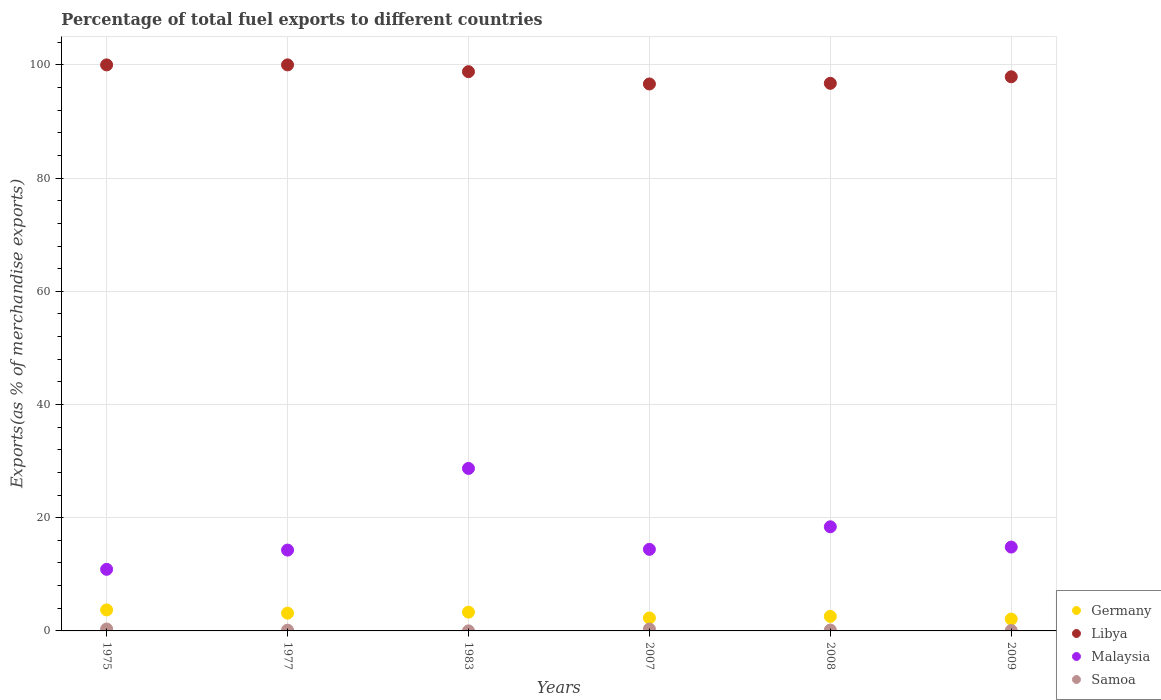How many different coloured dotlines are there?
Make the answer very short. 4. What is the percentage of exports to different countries in Libya in 1983?
Give a very brief answer. 98.8. Across all years, what is the maximum percentage of exports to different countries in Samoa?
Provide a succinct answer. 0.34. Across all years, what is the minimum percentage of exports to different countries in Germany?
Keep it short and to the point. 2.1. In which year was the percentage of exports to different countries in Libya maximum?
Offer a terse response. 1977. What is the total percentage of exports to different countries in Germany in the graph?
Give a very brief answer. 17.13. What is the difference between the percentage of exports to different countries in Germany in 2008 and that in 2009?
Ensure brevity in your answer.  0.47. What is the difference between the percentage of exports to different countries in Samoa in 1975 and the percentage of exports to different countries in Germany in 2009?
Offer a terse response. -1.76. What is the average percentage of exports to different countries in Germany per year?
Your answer should be very brief. 2.85. In the year 1983, what is the difference between the percentage of exports to different countries in Samoa and percentage of exports to different countries in Libya?
Keep it short and to the point. -98.79. In how many years, is the percentage of exports to different countries in Germany greater than 20 %?
Give a very brief answer. 0. What is the ratio of the percentage of exports to different countries in Libya in 1975 to that in 1983?
Keep it short and to the point. 1.01. Is the difference between the percentage of exports to different countries in Samoa in 1977 and 1983 greater than the difference between the percentage of exports to different countries in Libya in 1977 and 1983?
Your answer should be very brief. No. What is the difference between the highest and the second highest percentage of exports to different countries in Malaysia?
Ensure brevity in your answer.  10.31. What is the difference between the highest and the lowest percentage of exports to different countries in Samoa?
Your response must be concise. 0.33. In how many years, is the percentage of exports to different countries in Malaysia greater than the average percentage of exports to different countries in Malaysia taken over all years?
Give a very brief answer. 2. Is it the case that in every year, the sum of the percentage of exports to different countries in Malaysia and percentage of exports to different countries in Libya  is greater than the percentage of exports to different countries in Samoa?
Provide a succinct answer. Yes. How many dotlines are there?
Ensure brevity in your answer.  4. What is the difference between two consecutive major ticks on the Y-axis?
Offer a terse response. 20. Does the graph contain grids?
Your answer should be very brief. Yes. How are the legend labels stacked?
Offer a terse response. Vertical. What is the title of the graph?
Keep it short and to the point. Percentage of total fuel exports to different countries. Does "New Caledonia" appear as one of the legend labels in the graph?
Provide a succinct answer. No. What is the label or title of the Y-axis?
Your answer should be compact. Exports(as % of merchandise exports). What is the Exports(as % of merchandise exports) in Germany in 1975?
Your response must be concise. 3.71. What is the Exports(as % of merchandise exports) of Libya in 1975?
Your answer should be compact. 99.99. What is the Exports(as % of merchandise exports) of Malaysia in 1975?
Provide a succinct answer. 10.88. What is the Exports(as % of merchandise exports) of Samoa in 1975?
Provide a succinct answer. 0.34. What is the Exports(as % of merchandise exports) in Germany in 1977?
Offer a very short reply. 3.14. What is the Exports(as % of merchandise exports) in Libya in 1977?
Provide a short and direct response. 100. What is the Exports(as % of merchandise exports) of Malaysia in 1977?
Make the answer very short. 14.28. What is the Exports(as % of merchandise exports) of Samoa in 1977?
Your answer should be very brief. 0.13. What is the Exports(as % of merchandise exports) in Germany in 1983?
Give a very brief answer. 3.32. What is the Exports(as % of merchandise exports) in Libya in 1983?
Provide a short and direct response. 98.8. What is the Exports(as % of merchandise exports) in Malaysia in 1983?
Offer a terse response. 28.71. What is the Exports(as % of merchandise exports) of Samoa in 1983?
Your answer should be compact. 0.01. What is the Exports(as % of merchandise exports) in Germany in 2007?
Your response must be concise. 2.29. What is the Exports(as % of merchandise exports) in Libya in 2007?
Your answer should be compact. 96.62. What is the Exports(as % of merchandise exports) in Malaysia in 2007?
Keep it short and to the point. 14.41. What is the Exports(as % of merchandise exports) in Samoa in 2007?
Your response must be concise. 0.33. What is the Exports(as % of merchandise exports) of Germany in 2008?
Your answer should be compact. 2.57. What is the Exports(as % of merchandise exports) of Libya in 2008?
Make the answer very short. 96.74. What is the Exports(as % of merchandise exports) of Malaysia in 2008?
Keep it short and to the point. 18.4. What is the Exports(as % of merchandise exports) in Samoa in 2008?
Keep it short and to the point. 0.16. What is the Exports(as % of merchandise exports) in Germany in 2009?
Make the answer very short. 2.1. What is the Exports(as % of merchandise exports) of Libya in 2009?
Ensure brevity in your answer.  97.89. What is the Exports(as % of merchandise exports) in Malaysia in 2009?
Your response must be concise. 14.81. What is the Exports(as % of merchandise exports) in Samoa in 2009?
Offer a terse response. 0.07. Across all years, what is the maximum Exports(as % of merchandise exports) of Germany?
Provide a succinct answer. 3.71. Across all years, what is the maximum Exports(as % of merchandise exports) of Libya?
Your response must be concise. 100. Across all years, what is the maximum Exports(as % of merchandise exports) in Malaysia?
Provide a succinct answer. 28.71. Across all years, what is the maximum Exports(as % of merchandise exports) of Samoa?
Keep it short and to the point. 0.34. Across all years, what is the minimum Exports(as % of merchandise exports) of Germany?
Provide a short and direct response. 2.1. Across all years, what is the minimum Exports(as % of merchandise exports) in Libya?
Provide a short and direct response. 96.62. Across all years, what is the minimum Exports(as % of merchandise exports) in Malaysia?
Your response must be concise. 10.88. Across all years, what is the minimum Exports(as % of merchandise exports) of Samoa?
Provide a short and direct response. 0.01. What is the total Exports(as % of merchandise exports) of Germany in the graph?
Offer a terse response. 17.13. What is the total Exports(as % of merchandise exports) of Libya in the graph?
Offer a very short reply. 590.05. What is the total Exports(as % of merchandise exports) in Malaysia in the graph?
Your answer should be very brief. 101.49. What is the total Exports(as % of merchandise exports) in Samoa in the graph?
Make the answer very short. 1.04. What is the difference between the Exports(as % of merchandise exports) in Germany in 1975 and that in 1977?
Give a very brief answer. 0.57. What is the difference between the Exports(as % of merchandise exports) of Libya in 1975 and that in 1977?
Your response must be concise. -0. What is the difference between the Exports(as % of merchandise exports) in Malaysia in 1975 and that in 1977?
Your answer should be very brief. -3.4. What is the difference between the Exports(as % of merchandise exports) in Samoa in 1975 and that in 1977?
Make the answer very short. 0.2. What is the difference between the Exports(as % of merchandise exports) in Germany in 1975 and that in 1983?
Provide a succinct answer. 0.39. What is the difference between the Exports(as % of merchandise exports) of Libya in 1975 and that in 1983?
Keep it short and to the point. 1.2. What is the difference between the Exports(as % of merchandise exports) of Malaysia in 1975 and that in 1983?
Offer a terse response. -17.83. What is the difference between the Exports(as % of merchandise exports) in Samoa in 1975 and that in 1983?
Offer a terse response. 0.33. What is the difference between the Exports(as % of merchandise exports) of Germany in 1975 and that in 2007?
Provide a succinct answer. 1.42. What is the difference between the Exports(as % of merchandise exports) in Libya in 1975 and that in 2007?
Offer a very short reply. 3.37. What is the difference between the Exports(as % of merchandise exports) of Malaysia in 1975 and that in 2007?
Provide a succinct answer. -3.53. What is the difference between the Exports(as % of merchandise exports) of Samoa in 1975 and that in 2007?
Offer a very short reply. 0. What is the difference between the Exports(as % of merchandise exports) of Germany in 1975 and that in 2008?
Your response must be concise. 1.15. What is the difference between the Exports(as % of merchandise exports) in Libya in 1975 and that in 2008?
Offer a very short reply. 3.26. What is the difference between the Exports(as % of merchandise exports) in Malaysia in 1975 and that in 2008?
Your answer should be compact. -7.52. What is the difference between the Exports(as % of merchandise exports) of Samoa in 1975 and that in 2008?
Offer a terse response. 0.18. What is the difference between the Exports(as % of merchandise exports) of Germany in 1975 and that in 2009?
Offer a very short reply. 1.61. What is the difference between the Exports(as % of merchandise exports) in Libya in 1975 and that in 2009?
Offer a terse response. 2.1. What is the difference between the Exports(as % of merchandise exports) of Malaysia in 1975 and that in 2009?
Offer a very short reply. -3.93. What is the difference between the Exports(as % of merchandise exports) of Samoa in 1975 and that in 2009?
Your answer should be compact. 0.26. What is the difference between the Exports(as % of merchandise exports) of Germany in 1977 and that in 1983?
Provide a succinct answer. -0.18. What is the difference between the Exports(as % of merchandise exports) of Libya in 1977 and that in 1983?
Make the answer very short. 1.2. What is the difference between the Exports(as % of merchandise exports) in Malaysia in 1977 and that in 1983?
Ensure brevity in your answer.  -14.43. What is the difference between the Exports(as % of merchandise exports) in Samoa in 1977 and that in 1983?
Your response must be concise. 0.12. What is the difference between the Exports(as % of merchandise exports) of Germany in 1977 and that in 2007?
Your answer should be compact. 0.85. What is the difference between the Exports(as % of merchandise exports) in Libya in 1977 and that in 2007?
Offer a very short reply. 3.37. What is the difference between the Exports(as % of merchandise exports) of Malaysia in 1977 and that in 2007?
Your answer should be compact. -0.13. What is the difference between the Exports(as % of merchandise exports) of Samoa in 1977 and that in 2007?
Your answer should be very brief. -0.2. What is the difference between the Exports(as % of merchandise exports) in Germany in 1977 and that in 2008?
Provide a succinct answer. 0.58. What is the difference between the Exports(as % of merchandise exports) in Libya in 1977 and that in 2008?
Your answer should be compact. 3.26. What is the difference between the Exports(as % of merchandise exports) of Malaysia in 1977 and that in 2008?
Your response must be concise. -4.12. What is the difference between the Exports(as % of merchandise exports) in Samoa in 1977 and that in 2008?
Give a very brief answer. -0.03. What is the difference between the Exports(as % of merchandise exports) of Germany in 1977 and that in 2009?
Ensure brevity in your answer.  1.04. What is the difference between the Exports(as % of merchandise exports) in Libya in 1977 and that in 2009?
Provide a short and direct response. 2.1. What is the difference between the Exports(as % of merchandise exports) in Malaysia in 1977 and that in 2009?
Provide a succinct answer. -0.53. What is the difference between the Exports(as % of merchandise exports) of Samoa in 1977 and that in 2009?
Your answer should be compact. 0.06. What is the difference between the Exports(as % of merchandise exports) in Germany in 1983 and that in 2007?
Provide a short and direct response. 1.03. What is the difference between the Exports(as % of merchandise exports) of Libya in 1983 and that in 2007?
Offer a very short reply. 2.17. What is the difference between the Exports(as % of merchandise exports) in Malaysia in 1983 and that in 2007?
Keep it short and to the point. 14.29. What is the difference between the Exports(as % of merchandise exports) in Samoa in 1983 and that in 2007?
Offer a very short reply. -0.32. What is the difference between the Exports(as % of merchandise exports) in Germany in 1983 and that in 2008?
Offer a terse response. 0.75. What is the difference between the Exports(as % of merchandise exports) of Libya in 1983 and that in 2008?
Ensure brevity in your answer.  2.06. What is the difference between the Exports(as % of merchandise exports) of Malaysia in 1983 and that in 2008?
Ensure brevity in your answer.  10.31. What is the difference between the Exports(as % of merchandise exports) in Samoa in 1983 and that in 2008?
Your response must be concise. -0.15. What is the difference between the Exports(as % of merchandise exports) in Germany in 1983 and that in 2009?
Your response must be concise. 1.22. What is the difference between the Exports(as % of merchandise exports) in Libya in 1983 and that in 2009?
Your response must be concise. 0.9. What is the difference between the Exports(as % of merchandise exports) in Malaysia in 1983 and that in 2009?
Your answer should be very brief. 13.89. What is the difference between the Exports(as % of merchandise exports) in Samoa in 1983 and that in 2009?
Make the answer very short. -0.06. What is the difference between the Exports(as % of merchandise exports) in Germany in 2007 and that in 2008?
Offer a very short reply. -0.27. What is the difference between the Exports(as % of merchandise exports) of Libya in 2007 and that in 2008?
Offer a terse response. -0.11. What is the difference between the Exports(as % of merchandise exports) in Malaysia in 2007 and that in 2008?
Provide a succinct answer. -3.98. What is the difference between the Exports(as % of merchandise exports) in Samoa in 2007 and that in 2008?
Make the answer very short. 0.17. What is the difference between the Exports(as % of merchandise exports) of Germany in 2007 and that in 2009?
Give a very brief answer. 0.2. What is the difference between the Exports(as % of merchandise exports) of Libya in 2007 and that in 2009?
Make the answer very short. -1.27. What is the difference between the Exports(as % of merchandise exports) of Malaysia in 2007 and that in 2009?
Provide a short and direct response. -0.4. What is the difference between the Exports(as % of merchandise exports) of Samoa in 2007 and that in 2009?
Offer a terse response. 0.26. What is the difference between the Exports(as % of merchandise exports) in Germany in 2008 and that in 2009?
Keep it short and to the point. 0.47. What is the difference between the Exports(as % of merchandise exports) of Libya in 2008 and that in 2009?
Your answer should be compact. -1.16. What is the difference between the Exports(as % of merchandise exports) of Malaysia in 2008 and that in 2009?
Provide a short and direct response. 3.58. What is the difference between the Exports(as % of merchandise exports) in Samoa in 2008 and that in 2009?
Your response must be concise. 0.09. What is the difference between the Exports(as % of merchandise exports) in Germany in 1975 and the Exports(as % of merchandise exports) in Libya in 1977?
Make the answer very short. -96.29. What is the difference between the Exports(as % of merchandise exports) of Germany in 1975 and the Exports(as % of merchandise exports) of Malaysia in 1977?
Ensure brevity in your answer.  -10.57. What is the difference between the Exports(as % of merchandise exports) of Germany in 1975 and the Exports(as % of merchandise exports) of Samoa in 1977?
Your response must be concise. 3.58. What is the difference between the Exports(as % of merchandise exports) of Libya in 1975 and the Exports(as % of merchandise exports) of Malaysia in 1977?
Give a very brief answer. 85.71. What is the difference between the Exports(as % of merchandise exports) of Libya in 1975 and the Exports(as % of merchandise exports) of Samoa in 1977?
Give a very brief answer. 99.86. What is the difference between the Exports(as % of merchandise exports) of Malaysia in 1975 and the Exports(as % of merchandise exports) of Samoa in 1977?
Keep it short and to the point. 10.75. What is the difference between the Exports(as % of merchandise exports) in Germany in 1975 and the Exports(as % of merchandise exports) in Libya in 1983?
Offer a very short reply. -95.09. What is the difference between the Exports(as % of merchandise exports) in Germany in 1975 and the Exports(as % of merchandise exports) in Malaysia in 1983?
Keep it short and to the point. -24.99. What is the difference between the Exports(as % of merchandise exports) of Germany in 1975 and the Exports(as % of merchandise exports) of Samoa in 1983?
Provide a short and direct response. 3.7. What is the difference between the Exports(as % of merchandise exports) in Libya in 1975 and the Exports(as % of merchandise exports) in Malaysia in 1983?
Make the answer very short. 71.29. What is the difference between the Exports(as % of merchandise exports) of Libya in 1975 and the Exports(as % of merchandise exports) of Samoa in 1983?
Ensure brevity in your answer.  99.98. What is the difference between the Exports(as % of merchandise exports) in Malaysia in 1975 and the Exports(as % of merchandise exports) in Samoa in 1983?
Your answer should be compact. 10.87. What is the difference between the Exports(as % of merchandise exports) in Germany in 1975 and the Exports(as % of merchandise exports) in Libya in 2007?
Give a very brief answer. -92.91. What is the difference between the Exports(as % of merchandise exports) in Germany in 1975 and the Exports(as % of merchandise exports) in Malaysia in 2007?
Provide a short and direct response. -10.7. What is the difference between the Exports(as % of merchandise exports) in Germany in 1975 and the Exports(as % of merchandise exports) in Samoa in 2007?
Make the answer very short. 3.38. What is the difference between the Exports(as % of merchandise exports) of Libya in 1975 and the Exports(as % of merchandise exports) of Malaysia in 2007?
Provide a short and direct response. 85.58. What is the difference between the Exports(as % of merchandise exports) in Libya in 1975 and the Exports(as % of merchandise exports) in Samoa in 2007?
Ensure brevity in your answer.  99.66. What is the difference between the Exports(as % of merchandise exports) in Malaysia in 1975 and the Exports(as % of merchandise exports) in Samoa in 2007?
Your answer should be compact. 10.55. What is the difference between the Exports(as % of merchandise exports) of Germany in 1975 and the Exports(as % of merchandise exports) of Libya in 2008?
Provide a succinct answer. -93.03. What is the difference between the Exports(as % of merchandise exports) in Germany in 1975 and the Exports(as % of merchandise exports) in Malaysia in 2008?
Provide a succinct answer. -14.68. What is the difference between the Exports(as % of merchandise exports) of Germany in 1975 and the Exports(as % of merchandise exports) of Samoa in 2008?
Your answer should be very brief. 3.55. What is the difference between the Exports(as % of merchandise exports) in Libya in 1975 and the Exports(as % of merchandise exports) in Malaysia in 2008?
Provide a short and direct response. 81.6. What is the difference between the Exports(as % of merchandise exports) in Libya in 1975 and the Exports(as % of merchandise exports) in Samoa in 2008?
Your answer should be compact. 99.83. What is the difference between the Exports(as % of merchandise exports) in Malaysia in 1975 and the Exports(as % of merchandise exports) in Samoa in 2008?
Offer a very short reply. 10.72. What is the difference between the Exports(as % of merchandise exports) of Germany in 1975 and the Exports(as % of merchandise exports) of Libya in 2009?
Your answer should be compact. -94.18. What is the difference between the Exports(as % of merchandise exports) of Germany in 1975 and the Exports(as % of merchandise exports) of Malaysia in 2009?
Offer a very short reply. -11.1. What is the difference between the Exports(as % of merchandise exports) of Germany in 1975 and the Exports(as % of merchandise exports) of Samoa in 2009?
Ensure brevity in your answer.  3.64. What is the difference between the Exports(as % of merchandise exports) of Libya in 1975 and the Exports(as % of merchandise exports) of Malaysia in 2009?
Keep it short and to the point. 85.18. What is the difference between the Exports(as % of merchandise exports) in Libya in 1975 and the Exports(as % of merchandise exports) in Samoa in 2009?
Give a very brief answer. 99.92. What is the difference between the Exports(as % of merchandise exports) of Malaysia in 1975 and the Exports(as % of merchandise exports) of Samoa in 2009?
Ensure brevity in your answer.  10.81. What is the difference between the Exports(as % of merchandise exports) of Germany in 1977 and the Exports(as % of merchandise exports) of Libya in 1983?
Your response must be concise. -95.66. What is the difference between the Exports(as % of merchandise exports) in Germany in 1977 and the Exports(as % of merchandise exports) in Malaysia in 1983?
Offer a very short reply. -25.56. What is the difference between the Exports(as % of merchandise exports) in Germany in 1977 and the Exports(as % of merchandise exports) in Samoa in 1983?
Offer a terse response. 3.13. What is the difference between the Exports(as % of merchandise exports) in Libya in 1977 and the Exports(as % of merchandise exports) in Malaysia in 1983?
Your response must be concise. 71.29. What is the difference between the Exports(as % of merchandise exports) in Libya in 1977 and the Exports(as % of merchandise exports) in Samoa in 1983?
Your answer should be compact. 99.99. What is the difference between the Exports(as % of merchandise exports) in Malaysia in 1977 and the Exports(as % of merchandise exports) in Samoa in 1983?
Your answer should be compact. 14.27. What is the difference between the Exports(as % of merchandise exports) in Germany in 1977 and the Exports(as % of merchandise exports) in Libya in 2007?
Provide a succinct answer. -93.48. What is the difference between the Exports(as % of merchandise exports) in Germany in 1977 and the Exports(as % of merchandise exports) in Malaysia in 2007?
Provide a short and direct response. -11.27. What is the difference between the Exports(as % of merchandise exports) in Germany in 1977 and the Exports(as % of merchandise exports) in Samoa in 2007?
Your answer should be compact. 2.81. What is the difference between the Exports(as % of merchandise exports) in Libya in 1977 and the Exports(as % of merchandise exports) in Malaysia in 2007?
Offer a very short reply. 85.59. What is the difference between the Exports(as % of merchandise exports) of Libya in 1977 and the Exports(as % of merchandise exports) of Samoa in 2007?
Ensure brevity in your answer.  99.66. What is the difference between the Exports(as % of merchandise exports) in Malaysia in 1977 and the Exports(as % of merchandise exports) in Samoa in 2007?
Offer a very short reply. 13.95. What is the difference between the Exports(as % of merchandise exports) in Germany in 1977 and the Exports(as % of merchandise exports) in Libya in 2008?
Keep it short and to the point. -93.6. What is the difference between the Exports(as % of merchandise exports) in Germany in 1977 and the Exports(as % of merchandise exports) in Malaysia in 2008?
Your answer should be very brief. -15.26. What is the difference between the Exports(as % of merchandise exports) of Germany in 1977 and the Exports(as % of merchandise exports) of Samoa in 2008?
Your answer should be compact. 2.98. What is the difference between the Exports(as % of merchandise exports) of Libya in 1977 and the Exports(as % of merchandise exports) of Malaysia in 2008?
Ensure brevity in your answer.  81.6. What is the difference between the Exports(as % of merchandise exports) in Libya in 1977 and the Exports(as % of merchandise exports) in Samoa in 2008?
Give a very brief answer. 99.84. What is the difference between the Exports(as % of merchandise exports) of Malaysia in 1977 and the Exports(as % of merchandise exports) of Samoa in 2008?
Your response must be concise. 14.12. What is the difference between the Exports(as % of merchandise exports) in Germany in 1977 and the Exports(as % of merchandise exports) in Libya in 2009?
Keep it short and to the point. -94.75. What is the difference between the Exports(as % of merchandise exports) of Germany in 1977 and the Exports(as % of merchandise exports) of Malaysia in 2009?
Provide a short and direct response. -11.67. What is the difference between the Exports(as % of merchandise exports) in Germany in 1977 and the Exports(as % of merchandise exports) in Samoa in 2009?
Offer a very short reply. 3.07. What is the difference between the Exports(as % of merchandise exports) in Libya in 1977 and the Exports(as % of merchandise exports) in Malaysia in 2009?
Keep it short and to the point. 85.19. What is the difference between the Exports(as % of merchandise exports) in Libya in 1977 and the Exports(as % of merchandise exports) in Samoa in 2009?
Provide a succinct answer. 99.93. What is the difference between the Exports(as % of merchandise exports) in Malaysia in 1977 and the Exports(as % of merchandise exports) in Samoa in 2009?
Offer a very short reply. 14.21. What is the difference between the Exports(as % of merchandise exports) of Germany in 1983 and the Exports(as % of merchandise exports) of Libya in 2007?
Keep it short and to the point. -93.31. What is the difference between the Exports(as % of merchandise exports) of Germany in 1983 and the Exports(as % of merchandise exports) of Malaysia in 2007?
Your answer should be very brief. -11.09. What is the difference between the Exports(as % of merchandise exports) in Germany in 1983 and the Exports(as % of merchandise exports) in Samoa in 2007?
Keep it short and to the point. 2.99. What is the difference between the Exports(as % of merchandise exports) in Libya in 1983 and the Exports(as % of merchandise exports) in Malaysia in 2007?
Keep it short and to the point. 84.39. What is the difference between the Exports(as % of merchandise exports) of Libya in 1983 and the Exports(as % of merchandise exports) of Samoa in 2007?
Give a very brief answer. 98.46. What is the difference between the Exports(as % of merchandise exports) of Malaysia in 1983 and the Exports(as % of merchandise exports) of Samoa in 2007?
Offer a very short reply. 28.37. What is the difference between the Exports(as % of merchandise exports) of Germany in 1983 and the Exports(as % of merchandise exports) of Libya in 2008?
Your answer should be very brief. -93.42. What is the difference between the Exports(as % of merchandise exports) of Germany in 1983 and the Exports(as % of merchandise exports) of Malaysia in 2008?
Provide a short and direct response. -15.08. What is the difference between the Exports(as % of merchandise exports) of Germany in 1983 and the Exports(as % of merchandise exports) of Samoa in 2008?
Offer a very short reply. 3.16. What is the difference between the Exports(as % of merchandise exports) of Libya in 1983 and the Exports(as % of merchandise exports) of Malaysia in 2008?
Offer a terse response. 80.4. What is the difference between the Exports(as % of merchandise exports) in Libya in 1983 and the Exports(as % of merchandise exports) in Samoa in 2008?
Offer a very short reply. 98.64. What is the difference between the Exports(as % of merchandise exports) of Malaysia in 1983 and the Exports(as % of merchandise exports) of Samoa in 2008?
Provide a succinct answer. 28.55. What is the difference between the Exports(as % of merchandise exports) of Germany in 1983 and the Exports(as % of merchandise exports) of Libya in 2009?
Provide a succinct answer. -94.58. What is the difference between the Exports(as % of merchandise exports) in Germany in 1983 and the Exports(as % of merchandise exports) in Malaysia in 2009?
Your answer should be very brief. -11.49. What is the difference between the Exports(as % of merchandise exports) in Germany in 1983 and the Exports(as % of merchandise exports) in Samoa in 2009?
Give a very brief answer. 3.25. What is the difference between the Exports(as % of merchandise exports) of Libya in 1983 and the Exports(as % of merchandise exports) of Malaysia in 2009?
Give a very brief answer. 83.99. What is the difference between the Exports(as % of merchandise exports) in Libya in 1983 and the Exports(as % of merchandise exports) in Samoa in 2009?
Your answer should be compact. 98.73. What is the difference between the Exports(as % of merchandise exports) of Malaysia in 1983 and the Exports(as % of merchandise exports) of Samoa in 2009?
Give a very brief answer. 28.64. What is the difference between the Exports(as % of merchandise exports) of Germany in 2007 and the Exports(as % of merchandise exports) of Libya in 2008?
Keep it short and to the point. -94.44. What is the difference between the Exports(as % of merchandise exports) of Germany in 2007 and the Exports(as % of merchandise exports) of Malaysia in 2008?
Keep it short and to the point. -16.1. What is the difference between the Exports(as % of merchandise exports) in Germany in 2007 and the Exports(as % of merchandise exports) in Samoa in 2008?
Your answer should be very brief. 2.13. What is the difference between the Exports(as % of merchandise exports) in Libya in 2007 and the Exports(as % of merchandise exports) in Malaysia in 2008?
Give a very brief answer. 78.23. What is the difference between the Exports(as % of merchandise exports) in Libya in 2007 and the Exports(as % of merchandise exports) in Samoa in 2008?
Your response must be concise. 96.46. What is the difference between the Exports(as % of merchandise exports) in Malaysia in 2007 and the Exports(as % of merchandise exports) in Samoa in 2008?
Provide a succinct answer. 14.25. What is the difference between the Exports(as % of merchandise exports) in Germany in 2007 and the Exports(as % of merchandise exports) in Libya in 2009?
Your answer should be compact. -95.6. What is the difference between the Exports(as % of merchandise exports) in Germany in 2007 and the Exports(as % of merchandise exports) in Malaysia in 2009?
Make the answer very short. -12.52. What is the difference between the Exports(as % of merchandise exports) of Germany in 2007 and the Exports(as % of merchandise exports) of Samoa in 2009?
Your answer should be very brief. 2.22. What is the difference between the Exports(as % of merchandise exports) of Libya in 2007 and the Exports(as % of merchandise exports) of Malaysia in 2009?
Provide a succinct answer. 81.81. What is the difference between the Exports(as % of merchandise exports) of Libya in 2007 and the Exports(as % of merchandise exports) of Samoa in 2009?
Provide a short and direct response. 96.55. What is the difference between the Exports(as % of merchandise exports) in Malaysia in 2007 and the Exports(as % of merchandise exports) in Samoa in 2009?
Make the answer very short. 14.34. What is the difference between the Exports(as % of merchandise exports) in Germany in 2008 and the Exports(as % of merchandise exports) in Libya in 2009?
Keep it short and to the point. -95.33. What is the difference between the Exports(as % of merchandise exports) of Germany in 2008 and the Exports(as % of merchandise exports) of Malaysia in 2009?
Keep it short and to the point. -12.25. What is the difference between the Exports(as % of merchandise exports) of Germany in 2008 and the Exports(as % of merchandise exports) of Samoa in 2009?
Keep it short and to the point. 2.5. What is the difference between the Exports(as % of merchandise exports) of Libya in 2008 and the Exports(as % of merchandise exports) of Malaysia in 2009?
Your answer should be very brief. 81.93. What is the difference between the Exports(as % of merchandise exports) of Libya in 2008 and the Exports(as % of merchandise exports) of Samoa in 2009?
Make the answer very short. 96.67. What is the difference between the Exports(as % of merchandise exports) of Malaysia in 2008 and the Exports(as % of merchandise exports) of Samoa in 2009?
Provide a short and direct response. 18.33. What is the average Exports(as % of merchandise exports) in Germany per year?
Make the answer very short. 2.85. What is the average Exports(as % of merchandise exports) in Libya per year?
Make the answer very short. 98.34. What is the average Exports(as % of merchandise exports) of Malaysia per year?
Keep it short and to the point. 16.91. What is the average Exports(as % of merchandise exports) of Samoa per year?
Provide a succinct answer. 0.17. In the year 1975, what is the difference between the Exports(as % of merchandise exports) of Germany and Exports(as % of merchandise exports) of Libya?
Your response must be concise. -96.28. In the year 1975, what is the difference between the Exports(as % of merchandise exports) of Germany and Exports(as % of merchandise exports) of Malaysia?
Offer a very short reply. -7.17. In the year 1975, what is the difference between the Exports(as % of merchandise exports) in Germany and Exports(as % of merchandise exports) in Samoa?
Your answer should be very brief. 3.38. In the year 1975, what is the difference between the Exports(as % of merchandise exports) of Libya and Exports(as % of merchandise exports) of Malaysia?
Offer a terse response. 89.11. In the year 1975, what is the difference between the Exports(as % of merchandise exports) of Libya and Exports(as % of merchandise exports) of Samoa?
Ensure brevity in your answer.  99.66. In the year 1975, what is the difference between the Exports(as % of merchandise exports) of Malaysia and Exports(as % of merchandise exports) of Samoa?
Offer a terse response. 10.55. In the year 1977, what is the difference between the Exports(as % of merchandise exports) in Germany and Exports(as % of merchandise exports) in Libya?
Your answer should be compact. -96.86. In the year 1977, what is the difference between the Exports(as % of merchandise exports) in Germany and Exports(as % of merchandise exports) in Malaysia?
Ensure brevity in your answer.  -11.14. In the year 1977, what is the difference between the Exports(as % of merchandise exports) of Germany and Exports(as % of merchandise exports) of Samoa?
Provide a succinct answer. 3.01. In the year 1977, what is the difference between the Exports(as % of merchandise exports) in Libya and Exports(as % of merchandise exports) in Malaysia?
Ensure brevity in your answer.  85.72. In the year 1977, what is the difference between the Exports(as % of merchandise exports) of Libya and Exports(as % of merchandise exports) of Samoa?
Keep it short and to the point. 99.87. In the year 1977, what is the difference between the Exports(as % of merchandise exports) in Malaysia and Exports(as % of merchandise exports) in Samoa?
Keep it short and to the point. 14.15. In the year 1983, what is the difference between the Exports(as % of merchandise exports) of Germany and Exports(as % of merchandise exports) of Libya?
Give a very brief answer. -95.48. In the year 1983, what is the difference between the Exports(as % of merchandise exports) of Germany and Exports(as % of merchandise exports) of Malaysia?
Provide a short and direct response. -25.39. In the year 1983, what is the difference between the Exports(as % of merchandise exports) in Germany and Exports(as % of merchandise exports) in Samoa?
Your response must be concise. 3.31. In the year 1983, what is the difference between the Exports(as % of merchandise exports) of Libya and Exports(as % of merchandise exports) of Malaysia?
Make the answer very short. 70.09. In the year 1983, what is the difference between the Exports(as % of merchandise exports) in Libya and Exports(as % of merchandise exports) in Samoa?
Ensure brevity in your answer.  98.79. In the year 1983, what is the difference between the Exports(as % of merchandise exports) of Malaysia and Exports(as % of merchandise exports) of Samoa?
Ensure brevity in your answer.  28.7. In the year 2007, what is the difference between the Exports(as % of merchandise exports) of Germany and Exports(as % of merchandise exports) of Libya?
Give a very brief answer. -94.33. In the year 2007, what is the difference between the Exports(as % of merchandise exports) in Germany and Exports(as % of merchandise exports) in Malaysia?
Your response must be concise. -12.12. In the year 2007, what is the difference between the Exports(as % of merchandise exports) of Germany and Exports(as % of merchandise exports) of Samoa?
Your answer should be very brief. 1.96. In the year 2007, what is the difference between the Exports(as % of merchandise exports) of Libya and Exports(as % of merchandise exports) of Malaysia?
Provide a short and direct response. 82.21. In the year 2007, what is the difference between the Exports(as % of merchandise exports) in Libya and Exports(as % of merchandise exports) in Samoa?
Offer a terse response. 96.29. In the year 2007, what is the difference between the Exports(as % of merchandise exports) in Malaysia and Exports(as % of merchandise exports) in Samoa?
Make the answer very short. 14.08. In the year 2008, what is the difference between the Exports(as % of merchandise exports) in Germany and Exports(as % of merchandise exports) in Libya?
Keep it short and to the point. -94.17. In the year 2008, what is the difference between the Exports(as % of merchandise exports) in Germany and Exports(as % of merchandise exports) in Malaysia?
Offer a terse response. -15.83. In the year 2008, what is the difference between the Exports(as % of merchandise exports) in Germany and Exports(as % of merchandise exports) in Samoa?
Offer a very short reply. 2.41. In the year 2008, what is the difference between the Exports(as % of merchandise exports) in Libya and Exports(as % of merchandise exports) in Malaysia?
Keep it short and to the point. 78.34. In the year 2008, what is the difference between the Exports(as % of merchandise exports) in Libya and Exports(as % of merchandise exports) in Samoa?
Your answer should be very brief. 96.58. In the year 2008, what is the difference between the Exports(as % of merchandise exports) of Malaysia and Exports(as % of merchandise exports) of Samoa?
Make the answer very short. 18.24. In the year 2009, what is the difference between the Exports(as % of merchandise exports) in Germany and Exports(as % of merchandise exports) in Libya?
Your answer should be compact. -95.8. In the year 2009, what is the difference between the Exports(as % of merchandise exports) in Germany and Exports(as % of merchandise exports) in Malaysia?
Ensure brevity in your answer.  -12.71. In the year 2009, what is the difference between the Exports(as % of merchandise exports) of Germany and Exports(as % of merchandise exports) of Samoa?
Provide a short and direct response. 2.03. In the year 2009, what is the difference between the Exports(as % of merchandise exports) in Libya and Exports(as % of merchandise exports) in Malaysia?
Offer a very short reply. 83.08. In the year 2009, what is the difference between the Exports(as % of merchandise exports) in Libya and Exports(as % of merchandise exports) in Samoa?
Your answer should be very brief. 97.82. In the year 2009, what is the difference between the Exports(as % of merchandise exports) in Malaysia and Exports(as % of merchandise exports) in Samoa?
Your response must be concise. 14.74. What is the ratio of the Exports(as % of merchandise exports) in Germany in 1975 to that in 1977?
Provide a short and direct response. 1.18. What is the ratio of the Exports(as % of merchandise exports) in Malaysia in 1975 to that in 1977?
Offer a terse response. 0.76. What is the ratio of the Exports(as % of merchandise exports) in Samoa in 1975 to that in 1977?
Offer a very short reply. 2.54. What is the ratio of the Exports(as % of merchandise exports) of Germany in 1975 to that in 1983?
Offer a very short reply. 1.12. What is the ratio of the Exports(as % of merchandise exports) in Libya in 1975 to that in 1983?
Offer a very short reply. 1.01. What is the ratio of the Exports(as % of merchandise exports) of Malaysia in 1975 to that in 1983?
Provide a succinct answer. 0.38. What is the ratio of the Exports(as % of merchandise exports) of Samoa in 1975 to that in 1983?
Your response must be concise. 37.58. What is the ratio of the Exports(as % of merchandise exports) in Germany in 1975 to that in 2007?
Make the answer very short. 1.62. What is the ratio of the Exports(as % of merchandise exports) of Libya in 1975 to that in 2007?
Your answer should be very brief. 1.03. What is the ratio of the Exports(as % of merchandise exports) of Malaysia in 1975 to that in 2007?
Offer a terse response. 0.76. What is the ratio of the Exports(as % of merchandise exports) of Samoa in 1975 to that in 2007?
Offer a terse response. 1.01. What is the ratio of the Exports(as % of merchandise exports) in Germany in 1975 to that in 2008?
Keep it short and to the point. 1.45. What is the ratio of the Exports(as % of merchandise exports) in Libya in 1975 to that in 2008?
Make the answer very short. 1.03. What is the ratio of the Exports(as % of merchandise exports) of Malaysia in 1975 to that in 2008?
Provide a succinct answer. 0.59. What is the ratio of the Exports(as % of merchandise exports) of Samoa in 1975 to that in 2008?
Keep it short and to the point. 2.1. What is the ratio of the Exports(as % of merchandise exports) of Germany in 1975 to that in 2009?
Your answer should be compact. 1.77. What is the ratio of the Exports(as % of merchandise exports) of Libya in 1975 to that in 2009?
Keep it short and to the point. 1.02. What is the ratio of the Exports(as % of merchandise exports) in Malaysia in 1975 to that in 2009?
Provide a short and direct response. 0.73. What is the ratio of the Exports(as % of merchandise exports) of Samoa in 1975 to that in 2009?
Your response must be concise. 4.72. What is the ratio of the Exports(as % of merchandise exports) in Germany in 1977 to that in 1983?
Ensure brevity in your answer.  0.95. What is the ratio of the Exports(as % of merchandise exports) in Libya in 1977 to that in 1983?
Offer a very short reply. 1.01. What is the ratio of the Exports(as % of merchandise exports) of Malaysia in 1977 to that in 1983?
Provide a short and direct response. 0.5. What is the ratio of the Exports(as % of merchandise exports) of Samoa in 1977 to that in 1983?
Offer a terse response. 14.77. What is the ratio of the Exports(as % of merchandise exports) in Germany in 1977 to that in 2007?
Provide a short and direct response. 1.37. What is the ratio of the Exports(as % of merchandise exports) in Libya in 1977 to that in 2007?
Provide a short and direct response. 1.03. What is the ratio of the Exports(as % of merchandise exports) in Malaysia in 1977 to that in 2007?
Provide a succinct answer. 0.99. What is the ratio of the Exports(as % of merchandise exports) in Samoa in 1977 to that in 2007?
Your answer should be very brief. 0.4. What is the ratio of the Exports(as % of merchandise exports) of Germany in 1977 to that in 2008?
Make the answer very short. 1.22. What is the ratio of the Exports(as % of merchandise exports) in Libya in 1977 to that in 2008?
Provide a succinct answer. 1.03. What is the ratio of the Exports(as % of merchandise exports) of Malaysia in 1977 to that in 2008?
Provide a short and direct response. 0.78. What is the ratio of the Exports(as % of merchandise exports) of Samoa in 1977 to that in 2008?
Make the answer very short. 0.82. What is the ratio of the Exports(as % of merchandise exports) in Germany in 1977 to that in 2009?
Give a very brief answer. 1.5. What is the ratio of the Exports(as % of merchandise exports) in Libya in 1977 to that in 2009?
Offer a terse response. 1.02. What is the ratio of the Exports(as % of merchandise exports) in Malaysia in 1977 to that in 2009?
Provide a short and direct response. 0.96. What is the ratio of the Exports(as % of merchandise exports) in Samoa in 1977 to that in 2009?
Your response must be concise. 1.86. What is the ratio of the Exports(as % of merchandise exports) in Germany in 1983 to that in 2007?
Your answer should be compact. 1.45. What is the ratio of the Exports(as % of merchandise exports) of Libya in 1983 to that in 2007?
Your answer should be compact. 1.02. What is the ratio of the Exports(as % of merchandise exports) in Malaysia in 1983 to that in 2007?
Your answer should be compact. 1.99. What is the ratio of the Exports(as % of merchandise exports) in Samoa in 1983 to that in 2007?
Make the answer very short. 0.03. What is the ratio of the Exports(as % of merchandise exports) in Germany in 1983 to that in 2008?
Your answer should be very brief. 1.29. What is the ratio of the Exports(as % of merchandise exports) in Libya in 1983 to that in 2008?
Your answer should be compact. 1.02. What is the ratio of the Exports(as % of merchandise exports) in Malaysia in 1983 to that in 2008?
Offer a terse response. 1.56. What is the ratio of the Exports(as % of merchandise exports) in Samoa in 1983 to that in 2008?
Offer a terse response. 0.06. What is the ratio of the Exports(as % of merchandise exports) of Germany in 1983 to that in 2009?
Offer a terse response. 1.58. What is the ratio of the Exports(as % of merchandise exports) in Libya in 1983 to that in 2009?
Make the answer very short. 1.01. What is the ratio of the Exports(as % of merchandise exports) of Malaysia in 1983 to that in 2009?
Offer a terse response. 1.94. What is the ratio of the Exports(as % of merchandise exports) of Samoa in 1983 to that in 2009?
Ensure brevity in your answer.  0.13. What is the ratio of the Exports(as % of merchandise exports) of Germany in 2007 to that in 2008?
Ensure brevity in your answer.  0.89. What is the ratio of the Exports(as % of merchandise exports) in Libya in 2007 to that in 2008?
Make the answer very short. 1. What is the ratio of the Exports(as % of merchandise exports) of Malaysia in 2007 to that in 2008?
Provide a short and direct response. 0.78. What is the ratio of the Exports(as % of merchandise exports) in Samoa in 2007 to that in 2008?
Give a very brief answer. 2.08. What is the ratio of the Exports(as % of merchandise exports) in Germany in 2007 to that in 2009?
Offer a terse response. 1.09. What is the ratio of the Exports(as % of merchandise exports) of Samoa in 2007 to that in 2009?
Make the answer very short. 4.69. What is the ratio of the Exports(as % of merchandise exports) of Germany in 2008 to that in 2009?
Make the answer very short. 1.22. What is the ratio of the Exports(as % of merchandise exports) in Malaysia in 2008 to that in 2009?
Your answer should be very brief. 1.24. What is the ratio of the Exports(as % of merchandise exports) of Samoa in 2008 to that in 2009?
Keep it short and to the point. 2.25. What is the difference between the highest and the second highest Exports(as % of merchandise exports) in Germany?
Give a very brief answer. 0.39. What is the difference between the highest and the second highest Exports(as % of merchandise exports) in Libya?
Provide a succinct answer. 0. What is the difference between the highest and the second highest Exports(as % of merchandise exports) of Malaysia?
Your answer should be compact. 10.31. What is the difference between the highest and the second highest Exports(as % of merchandise exports) of Samoa?
Your answer should be very brief. 0. What is the difference between the highest and the lowest Exports(as % of merchandise exports) in Germany?
Offer a terse response. 1.61. What is the difference between the highest and the lowest Exports(as % of merchandise exports) of Libya?
Ensure brevity in your answer.  3.37. What is the difference between the highest and the lowest Exports(as % of merchandise exports) of Malaysia?
Your answer should be very brief. 17.83. What is the difference between the highest and the lowest Exports(as % of merchandise exports) in Samoa?
Keep it short and to the point. 0.33. 